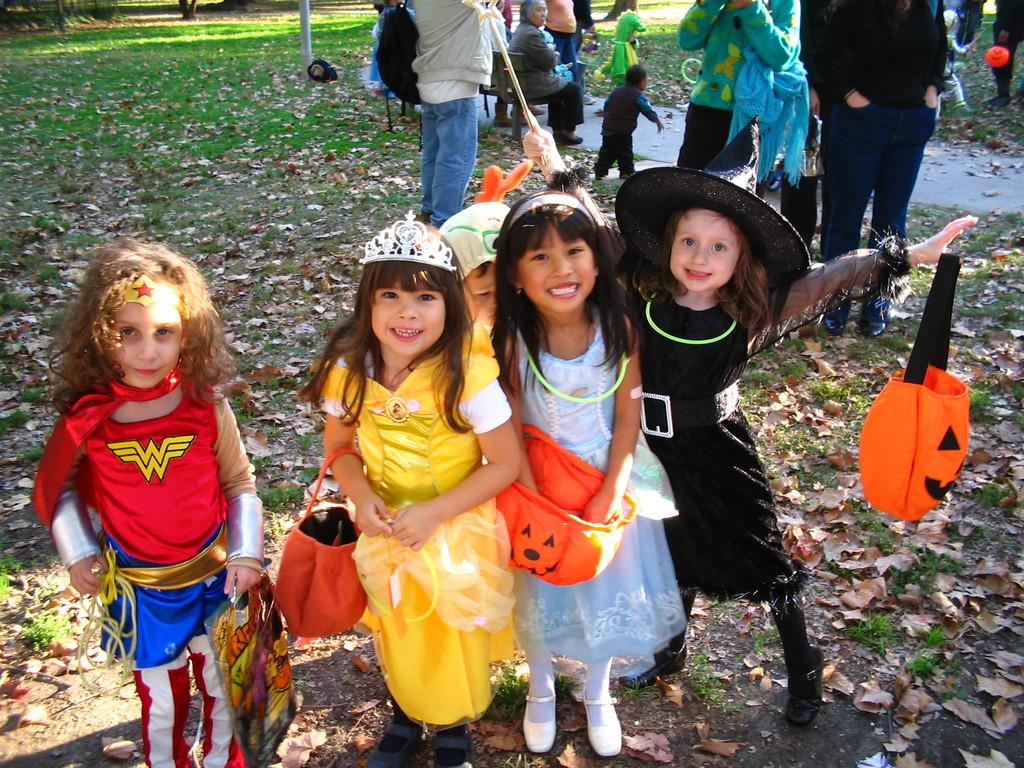How many girls are present in the image? There are five girls standing in the image. Where are the girls located in the image? The girls are at the bottom of the image. Can you describe anything in the background of the image? Yes, there are some persons in the background of the image. What type of destruction can be seen in the image? There is no destruction present in the image; it features five girls standing at the bottom and some persons in the background. What is the color of the lipstick worn by the girls in the image? There is no information about the girls wearing lipstick or any lipstick color in the image. 